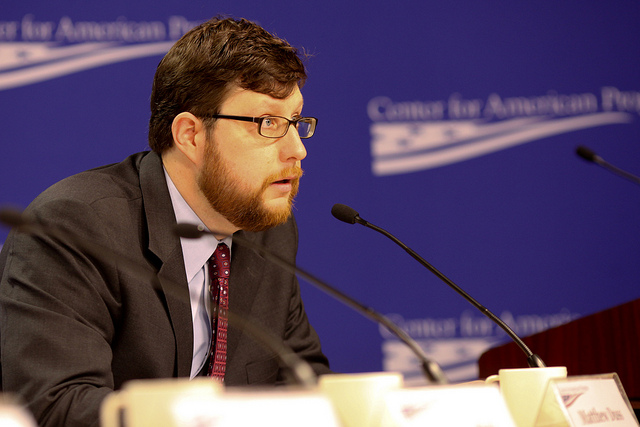Read and extract the text from this image. American 